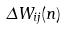<formula> <loc_0><loc_0><loc_500><loc_500>\Delta W _ { i j } ( n )</formula> 